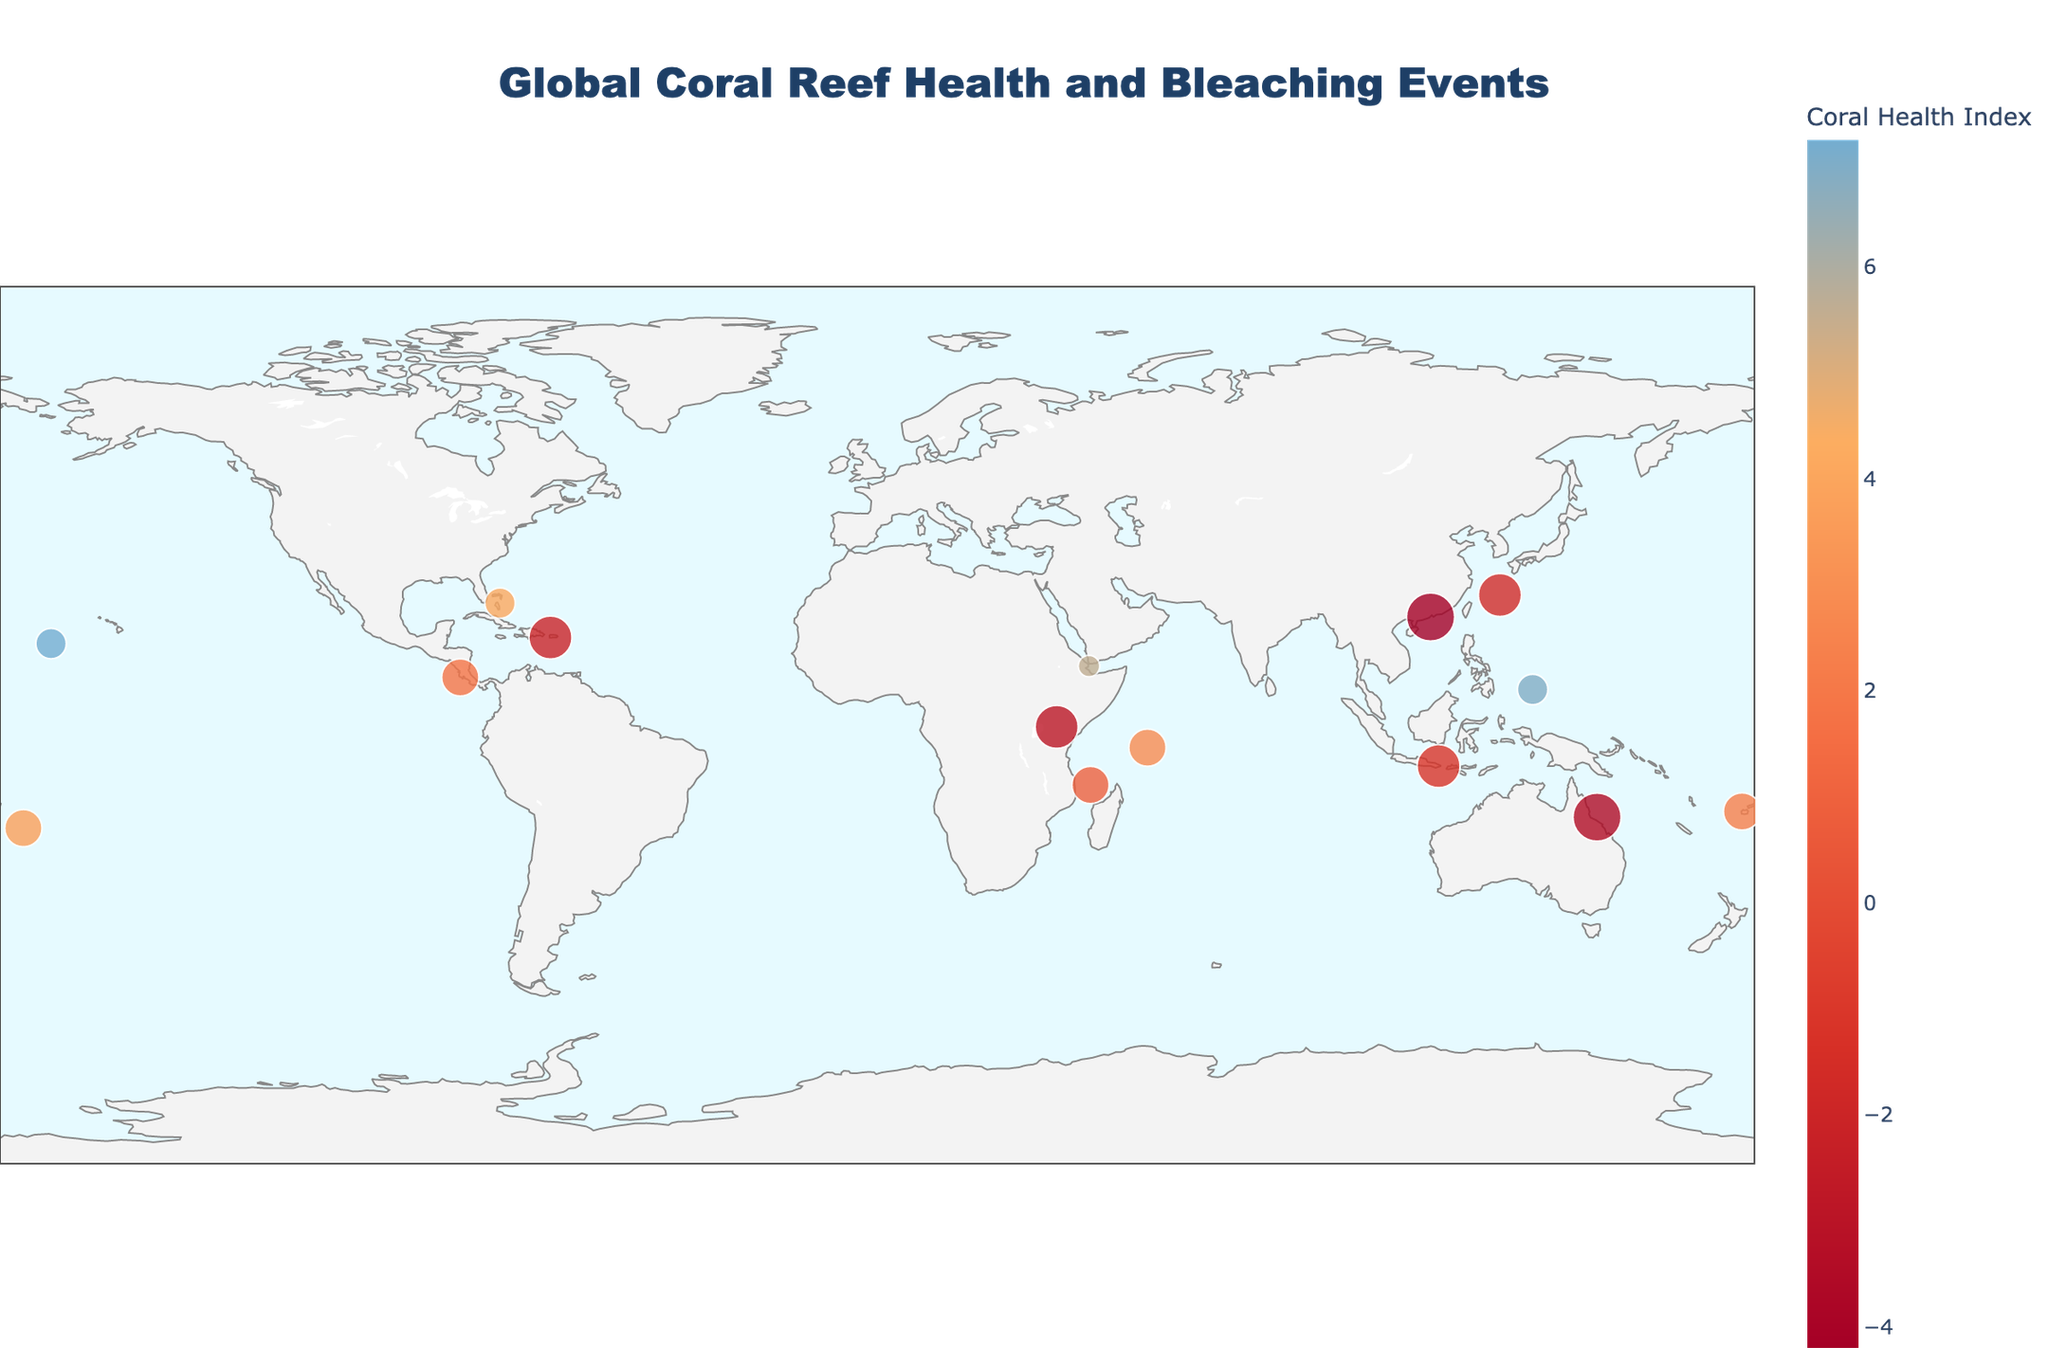What is the title of the plot? The title of the plot can be found at the top center of the figure in a larger font size compared to other text elements. It reads "Global Coral Reef Health and Bleaching Events".
Answer: Global Coral Reef Health and Bleaching Events Which location has the highest number of bleaching events? To find the location with the highest number of bleaching events, look for the largest circles on the plot. Hong Kong and the Great Barrier Reef both have the largest circles, indicating 5 bleaching events.
Answer: Hong Kong and Great Barrier Reef What is the range of the Coral Health Index? The range of the Coral Health Index can be determined by examining the color scale bar. The Coral Health Index ranges from a low of -4.2 (Hong Kong) to a high of 7.2 (Palmyra Atoll).
Answer: -4.2 to 7.2 How many locations are included in the plot? The total number of data points can be counted by looking at the number of circles on the plot. Each circle represents a location. There are 15 locations in total.
Answer: 15 Which location has the highest average ocean temperature change and what is its value? By checking the annotations on the plot, the highest average ocean temperature change is located in Hong Kong with a value of 1.3°C.
Answer: Hong Kong, 1.3°C Compare the Coral Health Index of the Great Barrier Reef and Seychelles. To compare the Coral Health Index, locate both points on the map and refer to the color scale. The Great Barrier Reef has an Index of -3.5 while the Seychelles has an Index of 2.8.
Answer: Great Barrier Reef: -3.5, Seychelles: 2.8 Which locations have a Coral Health Index less than 0? To find locations with a Coral Health Index less than 0, refer to the color-coded points on the map and the color scale. The locations are the Great Barrier Reef, Bali, Maldives, Hong Kong, Okinawa, and Puerto Rico.
Answer: Great Barrier Reef, Bali, Maldives, Hong Kong, Okinawa, Puerto Rico What is the relationship between bleaching events and average ocean temperature change for Palau? For Palau, check the size of the circle for bleaching events and the annotation for the temperature change. Palau has 2 bleaching events and an average ocean temperature change of 0.6°C.
Answer: 2 bleaching events, 0.6°C How does the average ocean temperature change in Puerto Rico compare to that in Palmyra Atoll? Compare the annotations on the plot; Puerto Rico has an average ocean temperature change of 1.1°C, while Palmyra Atoll has 0.8°C.
Answer: Puerto Rico: 1.1°C, Palmyra Atoll: 0.8°C What is the average Coral Health Index of all the locations? To calculate the average, sum all the Coral Health Index values and divide by the number of locations: (7.2 + -3.5 + 2.8 + 5.6 + 6.9 - 1.2 - 2.9 - 4.2 + 1.8 + 2.3 - 1.7 + 0.9 - 2.1) / 15 = 1.4867.
Answer: 1.49 